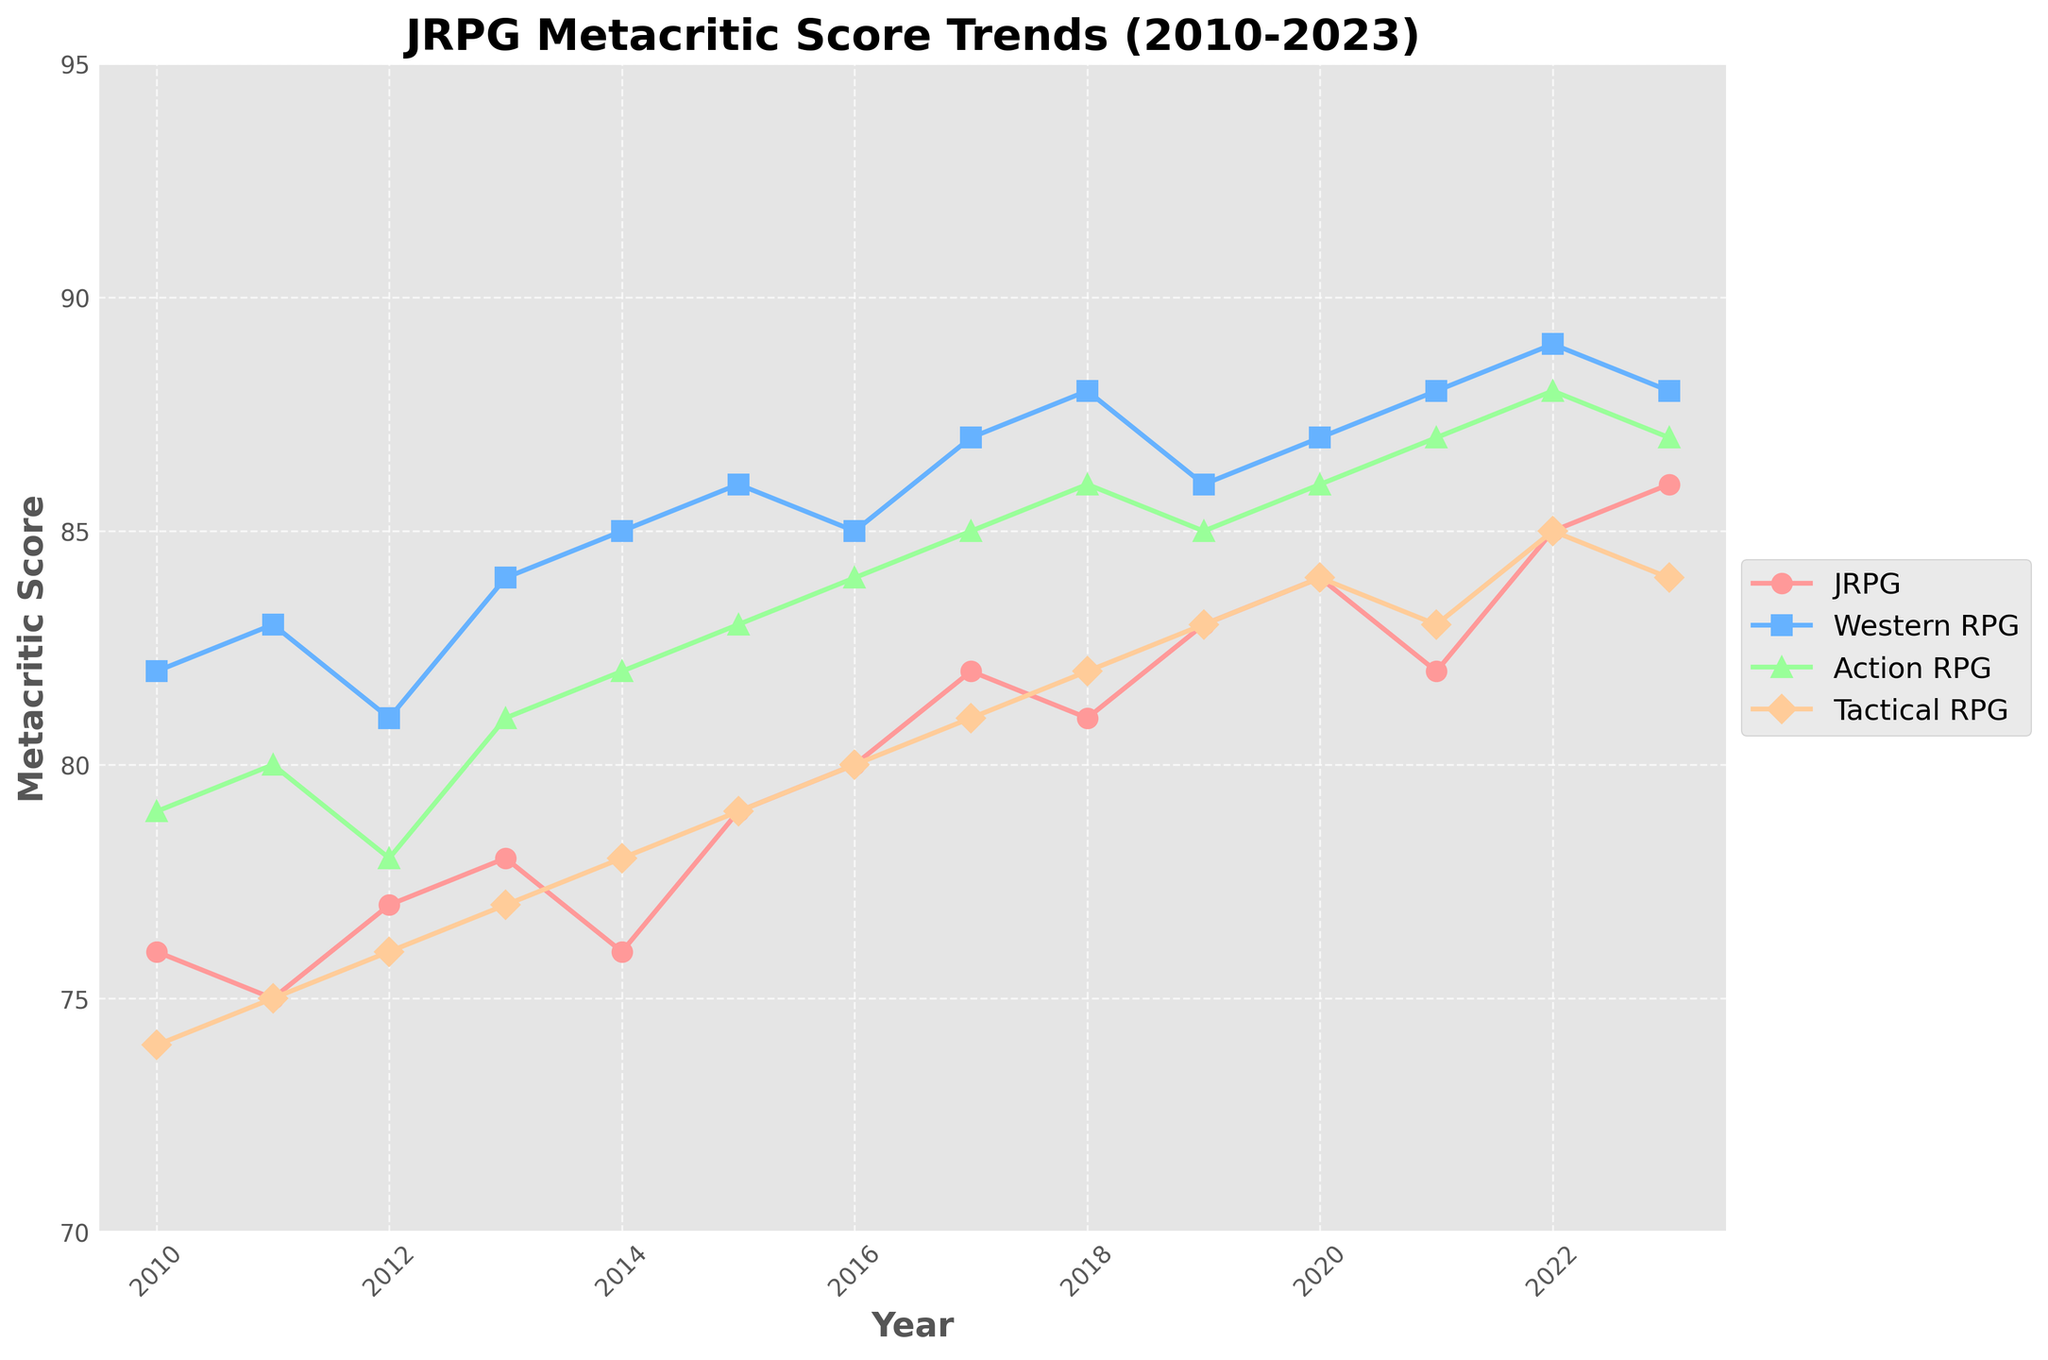Which subgenre has the highest Metacritic score in 2010? In 2010, the Western RPG has the highest Metacritic score of 82, which is visually the tallest point on the y-axis for that year.
Answer: Western RPG Has the average Metacritic score for JRPGs increased or decreased from 2010 to 2023? First, note the scores in 2010 (76) and 2023 (86). Compare these values to determine if there was an increase or decrease. The score increased from 76 to 86.
Answer: Increased In which year did Action RPGs and JRPGs both achieve the same Metacritic score? By visually comparing the lines for JRPGs and Action RPGs, we see they both have a Metacritic score of 87 in 2023.
Answer: 2023 How does the Metacritic score for Tactical RPGs in 2018 compare to that in 2020? From the chart, observe the position on the y-axis for Tactical RPGs in 2018 (82) and in 2020 (84). The score is higher in 2020.
Answer: 2020 is higher What is the total increase in Metacritic score for Western RPGs from 2010 to 2016? First, note the scores for Western RPGs in 2010 (82) and 2016 (85). Calculate the increase: 85 - 82 = 3.
Answer: 3 Which subgenre shows the most consistent trend in Metacritic scores over the years? Look for the subgenre with the least variance in scores. JRPG scores fluctuate between 75 and 86, while other genres have more varied trends.
Answer: JRPG In which year did all subgenres have the highest combined Metacritic scores? Sum the yearly scores for each genre: 2010 (311), 2011 (313), ..., 2023 (345). The highest combined score occurs in 2023 with a total of 345.
Answer: 2023 Compare the Metacritic score trends of Tactical RPGs and Action RPGs from 2016 to 2023. Which subgenre improved more significantly? Calculate the score difference for both subgenres: Tactical RPG: 84 - 80 = 4. Action RPG: 87 - 84 = 3. Tactical RPG improved more significantly.
Answer: Tactical RPGs 